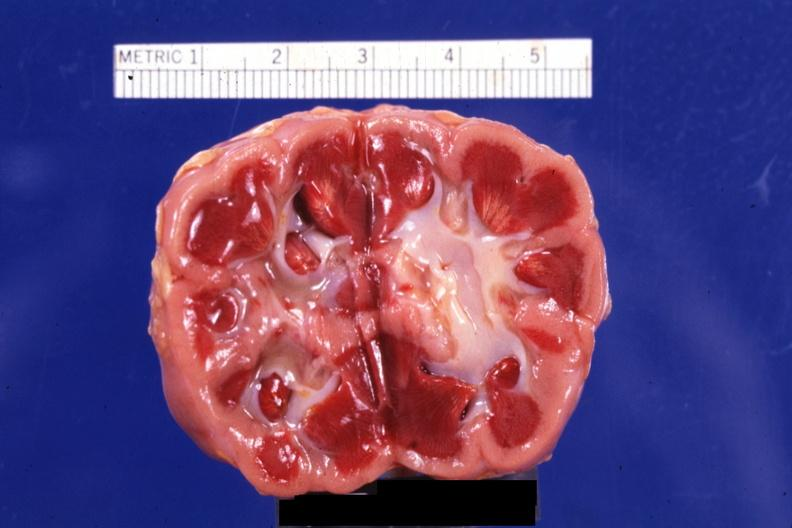s metastatic malignant ependymoma present?
Answer the question using a single word or phrase. No 